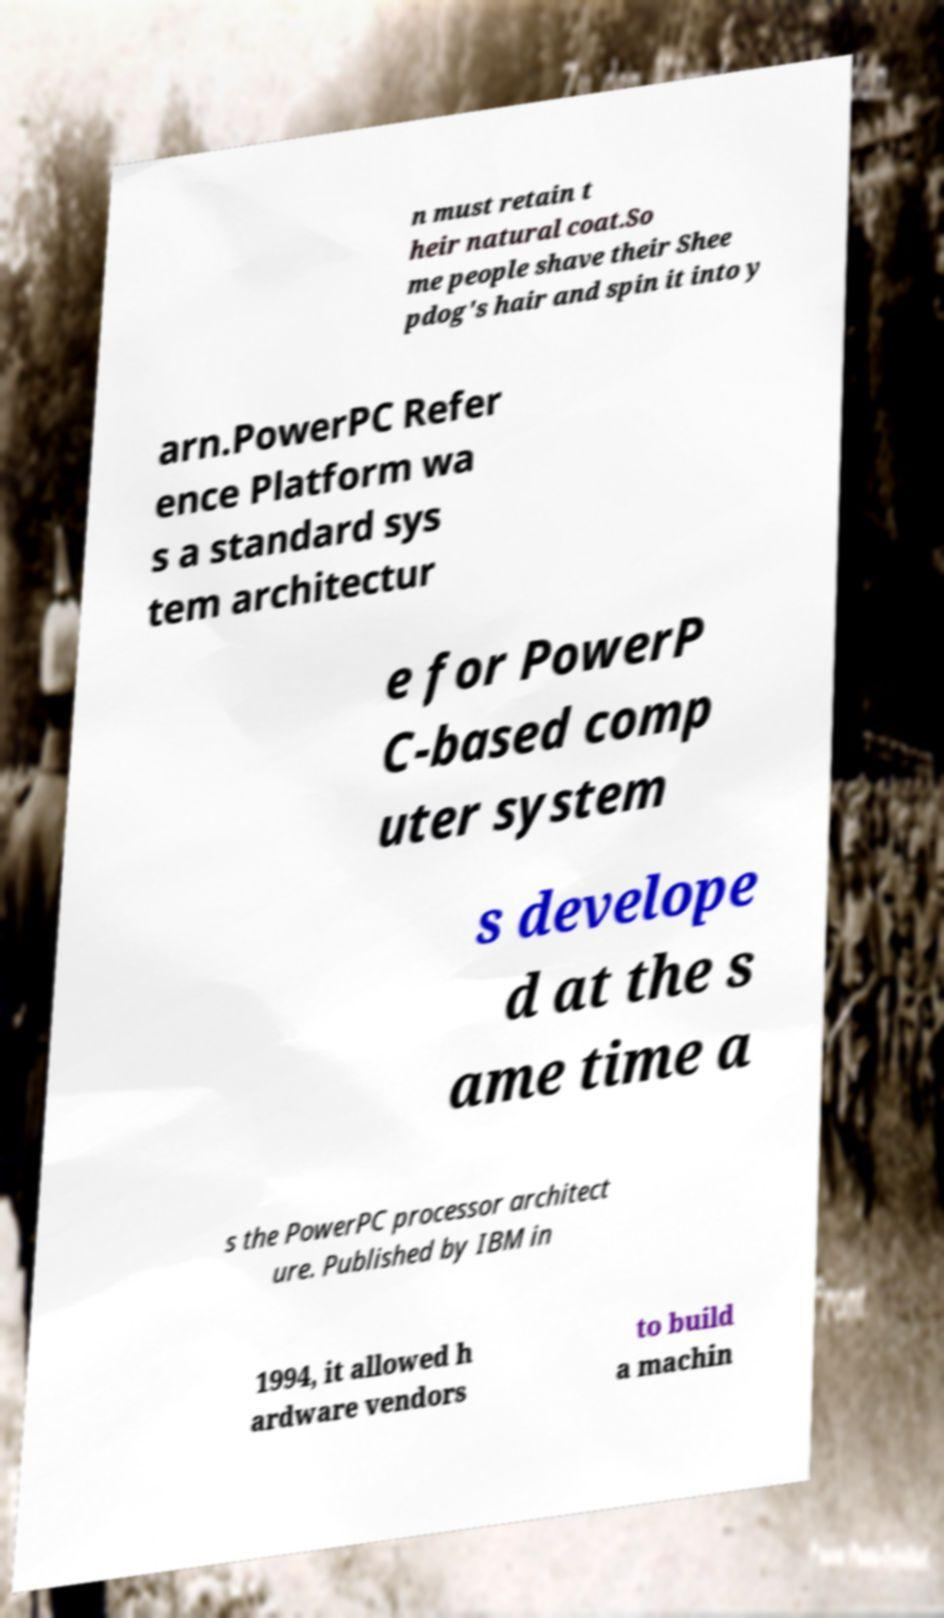There's text embedded in this image that I need extracted. Can you transcribe it verbatim? n must retain t heir natural coat.So me people shave their Shee pdog's hair and spin it into y arn.PowerPC Refer ence Platform wa s a standard sys tem architectur e for PowerP C-based comp uter system s develope d at the s ame time a s the PowerPC processor architect ure. Published by IBM in 1994, it allowed h ardware vendors to build a machin 